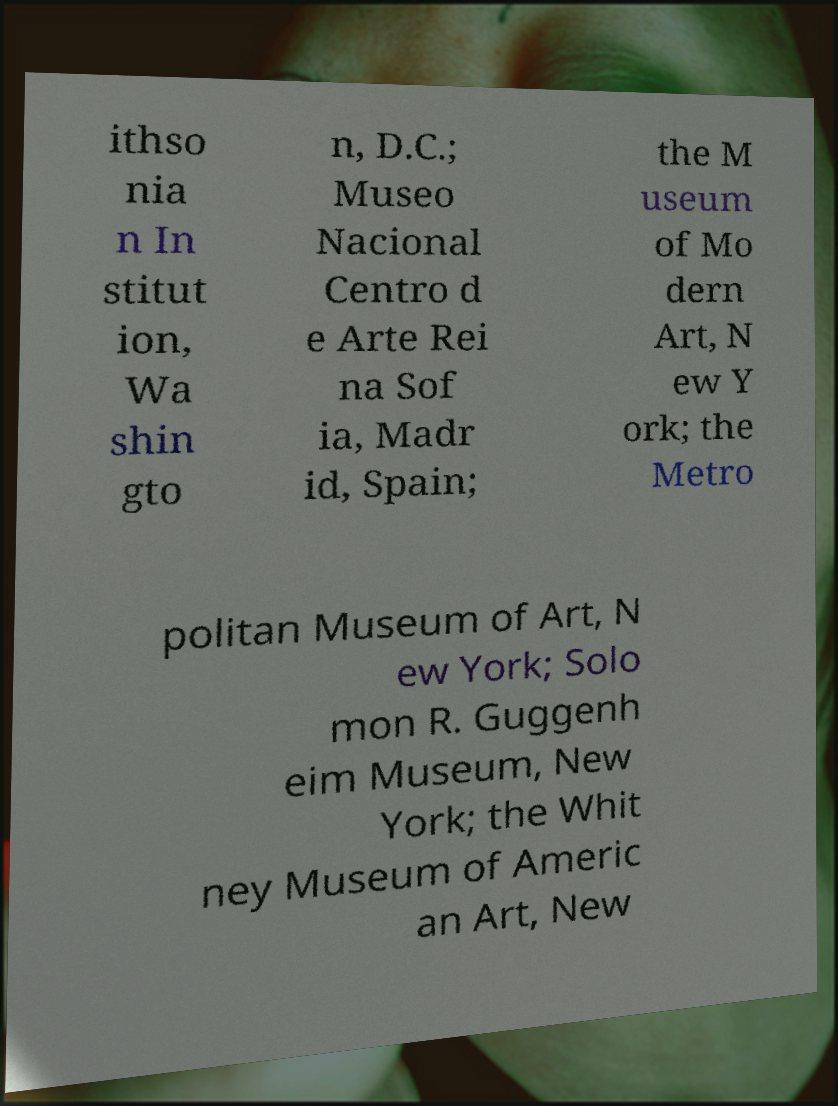For documentation purposes, I need the text within this image transcribed. Could you provide that? ithso nia n In stitut ion, Wa shin gto n, D.C.; Museo Nacional Centro d e Arte Rei na Sof ia, Madr id, Spain; the M useum of Mo dern Art, N ew Y ork; the Metro politan Museum of Art, N ew York; Solo mon R. Guggenh eim Museum, New York; the Whit ney Museum of Americ an Art, New 